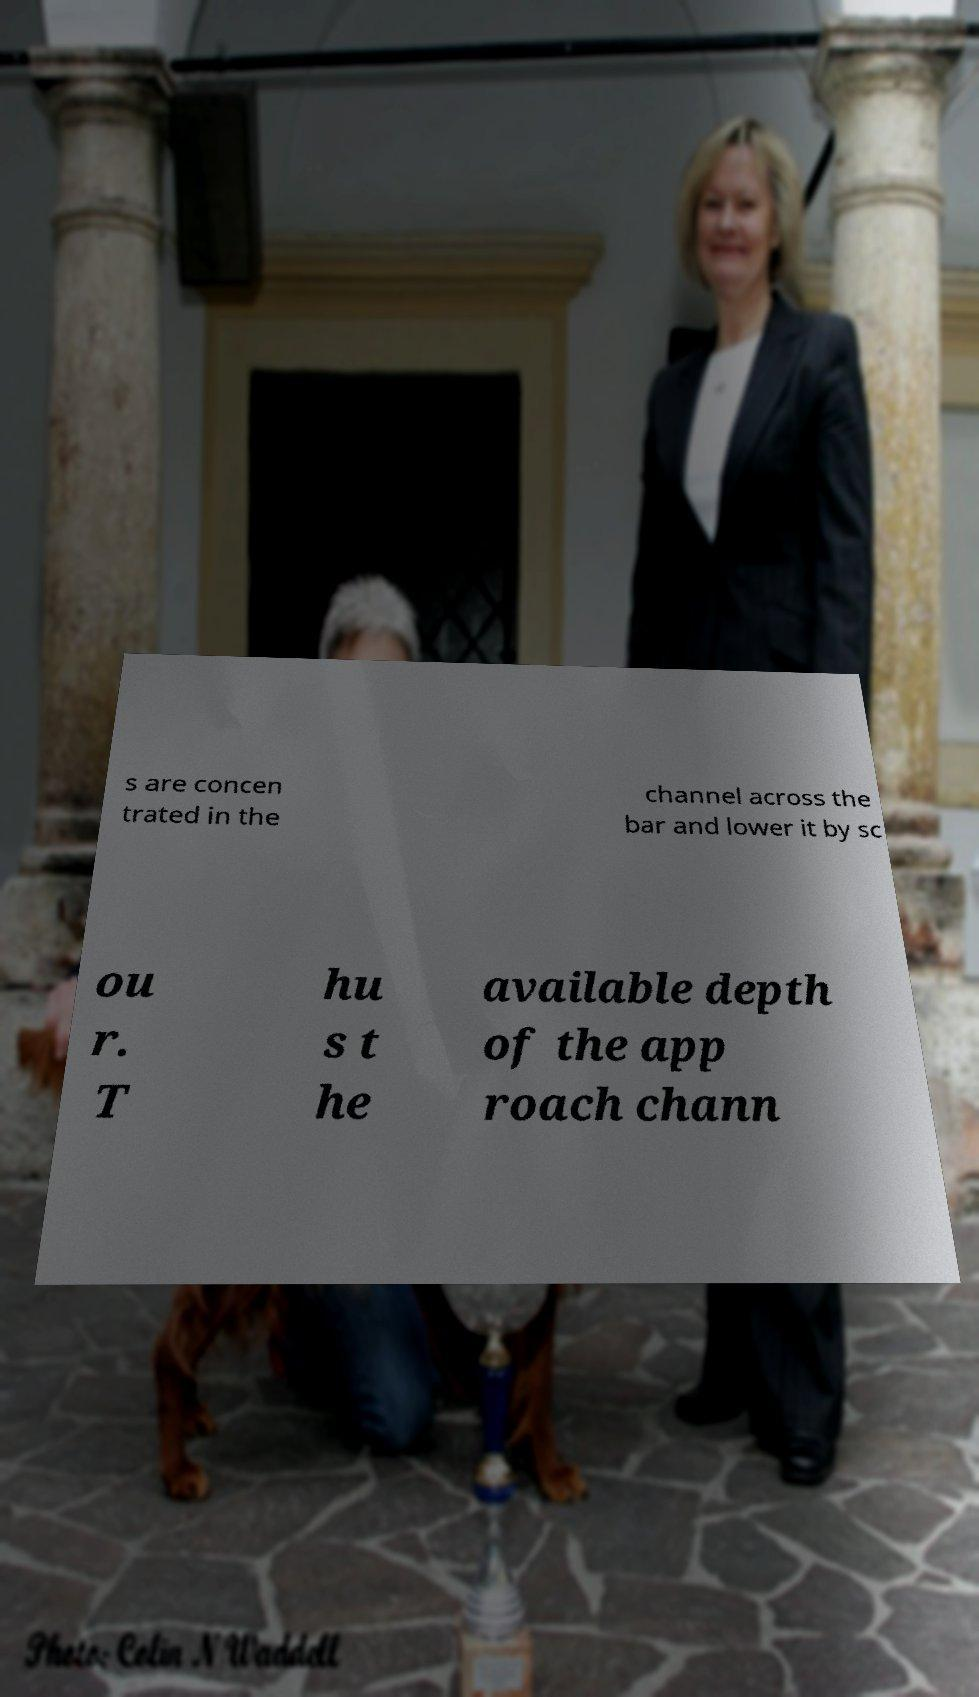Could you assist in decoding the text presented in this image and type it out clearly? s are concen trated in the channel across the bar and lower it by sc ou r. T hu s t he available depth of the app roach chann 